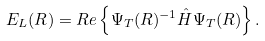Convert formula to latex. <formula><loc_0><loc_0><loc_500><loc_500>E _ { L } ( { R } ) = R e \left \{ \Psi _ { T } ( { R } ) ^ { - 1 } \hat { H } \Psi _ { T } ( { R } ) \right \} .</formula> 